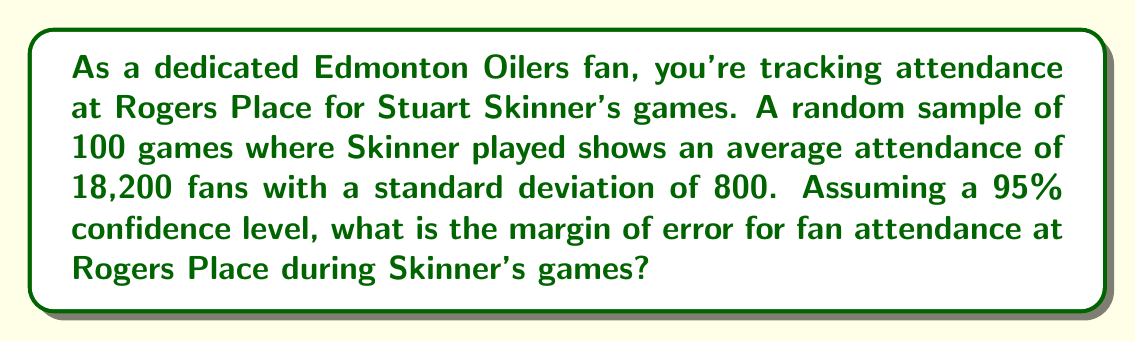Can you solve this math problem? Let's approach this step-by-step:

1) The formula for margin of error is:

   $$ ME = z \cdot \frac{\sigma}{\sqrt{n}} $$

   Where:
   - $z$ is the z-score for the desired confidence level
   - $\sigma$ is the standard deviation
   - $n$ is the sample size

2) We're given:
   - Confidence level = 95%
   - Sample size $(n) = 100$
   - Standard deviation $(\sigma) = 800$

3) For a 95% confidence level, the z-score is 1.96

4) Plugging these values into our formula:

   $$ ME = 1.96 \cdot \frac{800}{\sqrt{100}} $$

5) Simplify:
   $$ ME = 1.96 \cdot \frac{800}{10} = 1.96 \cdot 80 = 156.8 $$

6) Round to the nearest whole number (as we're dealing with people):

   $$ ME \approx 157 $$

Thus, the margin of error for fan attendance at Rogers Place during Stuart Skinner's games is approximately 157 fans.
Answer: 157 fans 